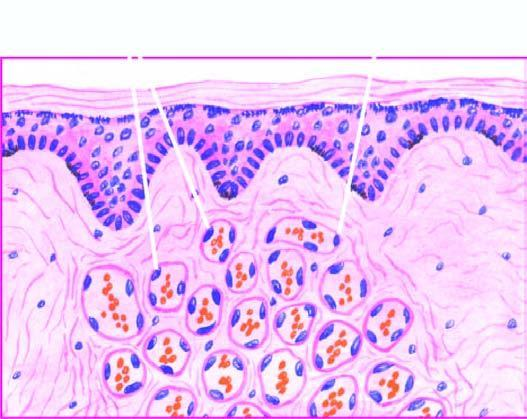re there capillaries lined by plump endothelial cells and containing blood?
Answer the question using a single word or phrase. Yes 